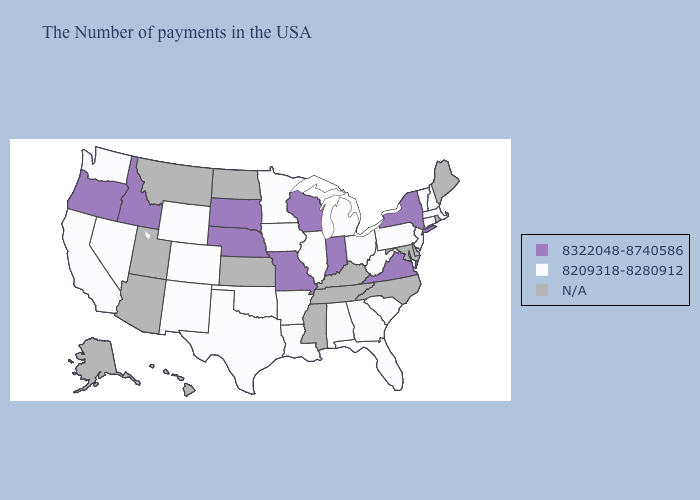What is the value of Vermont?
Be succinct. 8209318-8280912. Does Arkansas have the highest value in the South?
Short answer required. No. What is the highest value in the USA?
Give a very brief answer. 8322048-8740586. What is the value of Louisiana?
Quick response, please. 8209318-8280912. Among the states that border California , does Nevada have the highest value?
Answer briefly. No. What is the value of Louisiana?
Keep it brief. 8209318-8280912. What is the value of Nevada?
Concise answer only. 8209318-8280912. Does South Dakota have the lowest value in the MidWest?
Quick response, please. No. Does Idaho have the lowest value in the West?
Concise answer only. No. Does Massachusetts have the highest value in the Northeast?
Be succinct. No. What is the value of Virginia?
Quick response, please. 8322048-8740586. What is the value of Louisiana?
Be succinct. 8209318-8280912. What is the value of Colorado?
Concise answer only. 8209318-8280912. 